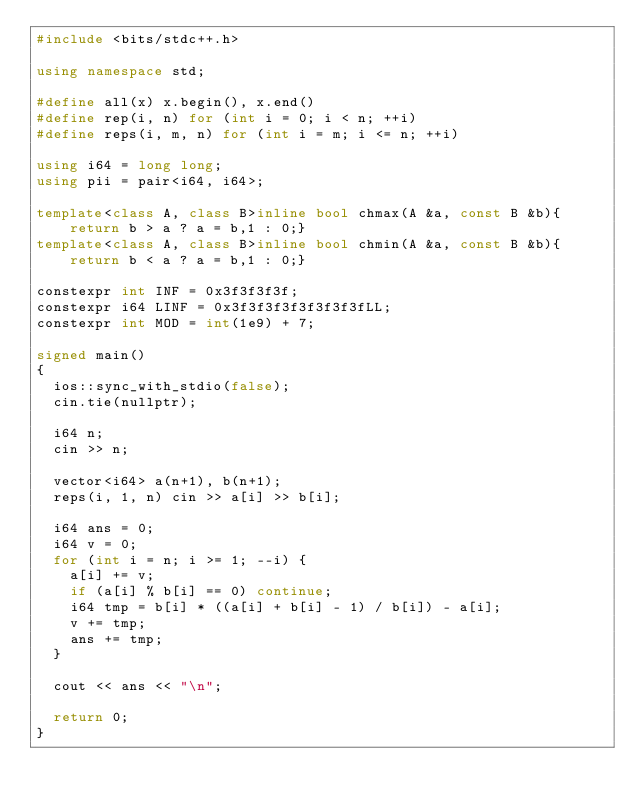<code> <loc_0><loc_0><loc_500><loc_500><_C++_>#include <bits/stdc++.h>

using namespace std;

#define all(x) x.begin(), x.end()
#define rep(i, n) for (int i = 0; i < n; ++i)
#define reps(i, m, n) for (int i = m; i <= n; ++i)

using i64 = long long;
using pii = pair<i64, i64>;

template<class A, class B>inline bool chmax(A &a, const B &b){return b > a ? a = b,1 : 0;}
template<class A, class B>inline bool chmin(A &a, const B &b){return b < a ? a = b,1 : 0;}

constexpr int INF = 0x3f3f3f3f;
constexpr i64 LINF = 0x3f3f3f3f3f3f3f3fLL;
constexpr int MOD = int(1e9) + 7;

signed main()
{
  ios::sync_with_stdio(false);
  cin.tie(nullptr);

  i64 n;
  cin >> n;

  vector<i64> a(n+1), b(n+1);
  reps(i, 1, n) cin >> a[i] >> b[i];

  i64 ans = 0;
  i64 v = 0;
  for (int i = n; i >= 1; --i) {
    a[i] += v;
    if (a[i] % b[i] == 0) continue;
    i64 tmp = b[i] * ((a[i] + b[i] - 1) / b[i]) - a[i];
    v += tmp;
    ans += tmp;
  }

  cout << ans << "\n";

  return 0;
}</code> 